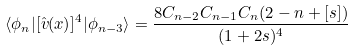Convert formula to latex. <formula><loc_0><loc_0><loc_500><loc_500>\langle \phi _ { n } | [ \hat { v } ( x ) ] ^ { 4 } | \phi _ { n - 3 } \rangle = \frac { 8 C _ { n - 2 } C _ { n - 1 } C _ { n } ( 2 - n + [ s ] ) } { ( 1 + 2 s ) ^ { 4 } }</formula> 